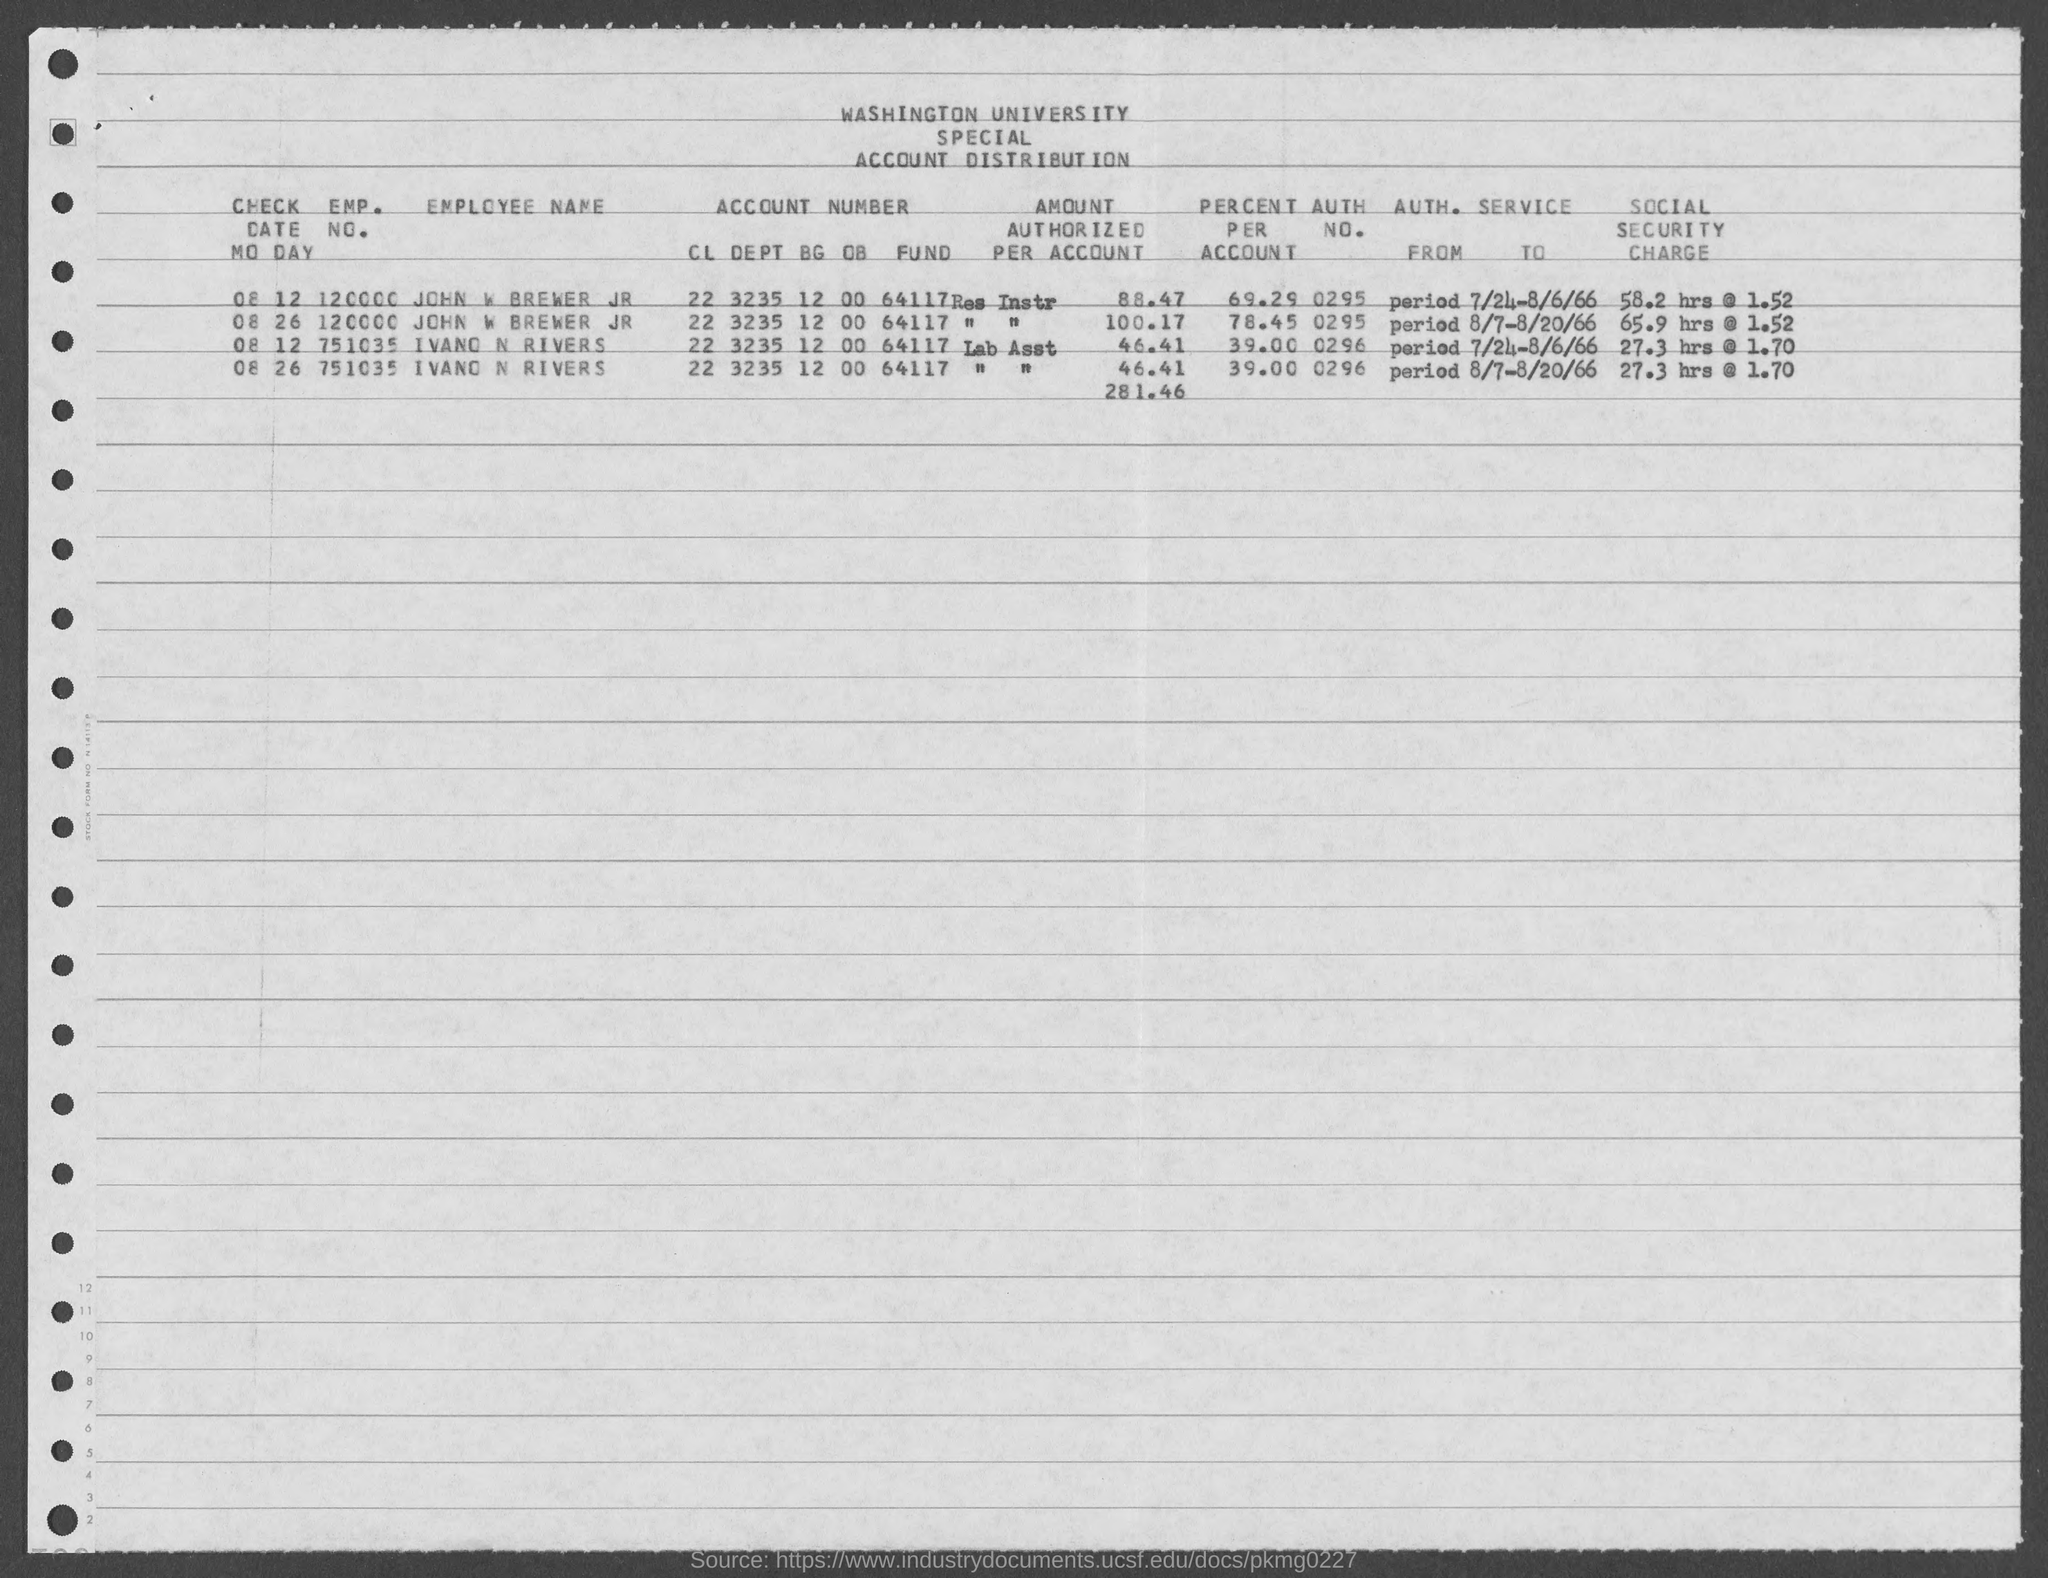Point out several critical features in this image. The given form mentions a university named "Washington University. What is the authentication number for Inavo N Rivers? What is the authorization number for John W. Brewer Jr.? The number is 0295. The value of "percent per account" for Ivano N Rivers, as mentioned in the given form, is 39%. The emp. no. of John W Brewer jr, as mentioned on the given page, is 120000. 